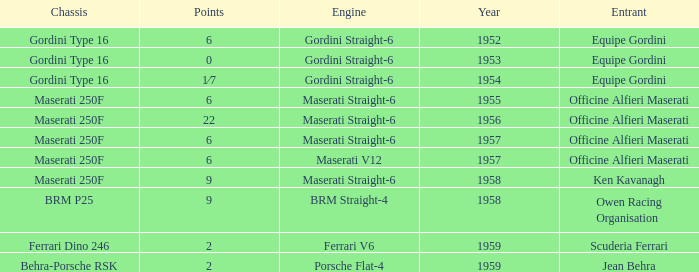What year engine does a ferrari v6 have? 1959.0. 